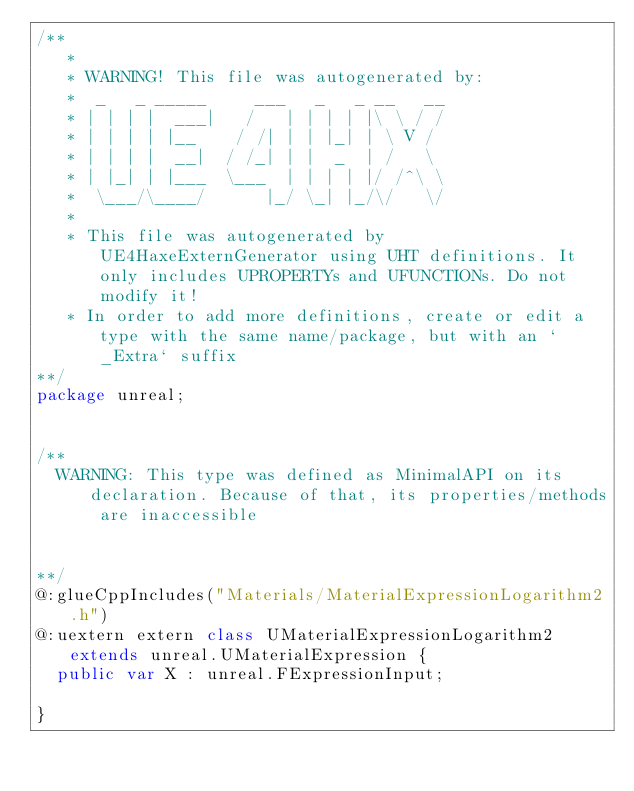Convert code to text. <code><loc_0><loc_0><loc_500><loc_500><_Haxe_>/**
   * 
   * WARNING! This file was autogenerated by: 
   *  _   _ _____     ___   _   _ __   __ 
   * | | | |  ___|   /   | | | | |\ \ / / 
   * | | | | |__    / /| | | |_| | \ V /  
   * | | | |  __|  / /_| | |  _  | /   \  
   * | |_| | |___  \___  | | | | |/ /^\ \ 
   *  \___/\____/      |_/ \_| |_/\/   \/ 
   * 
   * This file was autogenerated by UE4HaxeExternGenerator using UHT definitions. It only includes UPROPERTYs and UFUNCTIONs. Do not modify it!
   * In order to add more definitions, create or edit a type with the same name/package, but with an `_Extra` suffix
**/
package unreal;


/**
  WARNING: This type was defined as MinimalAPI on its declaration. Because of that, its properties/methods are inaccessible
  
  
**/
@:glueCppIncludes("Materials/MaterialExpressionLogarithm2.h")
@:uextern extern class UMaterialExpressionLogarithm2 extends unreal.UMaterialExpression {
  public var X : unreal.FExpressionInput;
  
}
</code> 